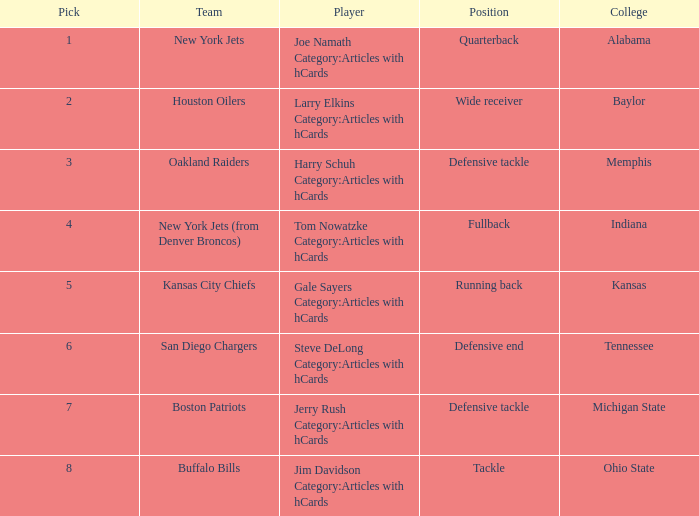The New York Jets picked someone from what college? Alabama. 